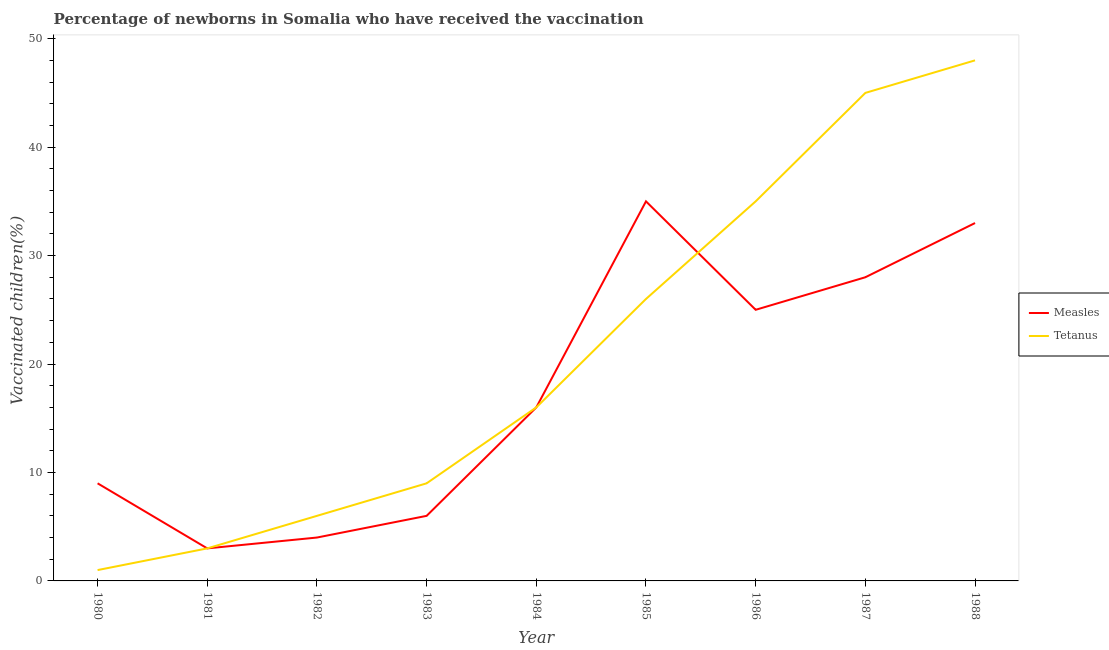What is the percentage of newborns who received vaccination for measles in 1985?
Make the answer very short. 35. Across all years, what is the maximum percentage of newborns who received vaccination for tetanus?
Give a very brief answer. 48. Across all years, what is the minimum percentage of newborns who received vaccination for tetanus?
Your answer should be very brief. 1. What is the total percentage of newborns who received vaccination for tetanus in the graph?
Make the answer very short. 189. What is the difference between the percentage of newborns who received vaccination for measles in 1983 and that in 1984?
Offer a very short reply. -10. What is the difference between the percentage of newborns who received vaccination for measles in 1986 and the percentage of newborns who received vaccination for tetanus in 1987?
Your response must be concise. -20. What is the average percentage of newborns who received vaccination for tetanus per year?
Your response must be concise. 21. In the year 1986, what is the difference between the percentage of newborns who received vaccination for tetanus and percentage of newborns who received vaccination for measles?
Provide a succinct answer. 10. In how many years, is the percentage of newborns who received vaccination for measles greater than 18 %?
Offer a very short reply. 4. What is the ratio of the percentage of newborns who received vaccination for tetanus in 1986 to that in 1988?
Offer a very short reply. 0.73. What is the difference between the highest and the second highest percentage of newborns who received vaccination for tetanus?
Ensure brevity in your answer.  3. What is the difference between the highest and the lowest percentage of newborns who received vaccination for tetanus?
Ensure brevity in your answer.  47. In how many years, is the percentage of newborns who received vaccination for tetanus greater than the average percentage of newborns who received vaccination for tetanus taken over all years?
Provide a short and direct response. 4. Does the percentage of newborns who received vaccination for tetanus monotonically increase over the years?
Your answer should be compact. Yes. Is the percentage of newborns who received vaccination for tetanus strictly greater than the percentage of newborns who received vaccination for measles over the years?
Provide a succinct answer. No. What is the difference between two consecutive major ticks on the Y-axis?
Keep it short and to the point. 10. Does the graph contain any zero values?
Your answer should be very brief. No. Where does the legend appear in the graph?
Offer a terse response. Center right. How many legend labels are there?
Your answer should be compact. 2. What is the title of the graph?
Keep it short and to the point. Percentage of newborns in Somalia who have received the vaccination. What is the label or title of the X-axis?
Ensure brevity in your answer.  Year. What is the label or title of the Y-axis?
Provide a short and direct response. Vaccinated children(%)
. What is the Vaccinated children(%)
 in Measles in 1980?
Give a very brief answer. 9. What is the Vaccinated children(%)
 of Tetanus in 1980?
Make the answer very short. 1. What is the Vaccinated children(%)
 in Measles in 1982?
Offer a terse response. 4. What is the Vaccinated children(%)
 of Measles in 1983?
Provide a succinct answer. 6. What is the Vaccinated children(%)
 of Measles in 1984?
Your answer should be compact. 16. What is the Vaccinated children(%)
 in Tetanus in 1984?
Offer a very short reply. 16. What is the Vaccinated children(%)
 of Tetanus in 1986?
Give a very brief answer. 35. Across all years, what is the minimum Vaccinated children(%)
 of Tetanus?
Your answer should be very brief. 1. What is the total Vaccinated children(%)
 of Measles in the graph?
Make the answer very short. 159. What is the total Vaccinated children(%)
 of Tetanus in the graph?
Give a very brief answer. 189. What is the difference between the Vaccinated children(%)
 of Measles in 1980 and that in 1981?
Keep it short and to the point. 6. What is the difference between the Vaccinated children(%)
 in Tetanus in 1980 and that in 1981?
Your response must be concise. -2. What is the difference between the Vaccinated children(%)
 in Measles in 1980 and that in 1983?
Your response must be concise. 3. What is the difference between the Vaccinated children(%)
 in Tetanus in 1980 and that in 1985?
Keep it short and to the point. -25. What is the difference between the Vaccinated children(%)
 of Tetanus in 1980 and that in 1986?
Offer a terse response. -34. What is the difference between the Vaccinated children(%)
 of Measles in 1980 and that in 1987?
Provide a succinct answer. -19. What is the difference between the Vaccinated children(%)
 of Tetanus in 1980 and that in 1987?
Your answer should be very brief. -44. What is the difference between the Vaccinated children(%)
 of Measles in 1980 and that in 1988?
Your answer should be compact. -24. What is the difference between the Vaccinated children(%)
 in Tetanus in 1980 and that in 1988?
Ensure brevity in your answer.  -47. What is the difference between the Vaccinated children(%)
 of Measles in 1981 and that in 1982?
Give a very brief answer. -1. What is the difference between the Vaccinated children(%)
 in Measles in 1981 and that in 1983?
Keep it short and to the point. -3. What is the difference between the Vaccinated children(%)
 in Measles in 1981 and that in 1984?
Your answer should be very brief. -13. What is the difference between the Vaccinated children(%)
 of Measles in 1981 and that in 1985?
Offer a very short reply. -32. What is the difference between the Vaccinated children(%)
 in Tetanus in 1981 and that in 1986?
Ensure brevity in your answer.  -32. What is the difference between the Vaccinated children(%)
 in Measles in 1981 and that in 1987?
Make the answer very short. -25. What is the difference between the Vaccinated children(%)
 of Tetanus in 1981 and that in 1987?
Your answer should be compact. -42. What is the difference between the Vaccinated children(%)
 of Tetanus in 1981 and that in 1988?
Provide a succinct answer. -45. What is the difference between the Vaccinated children(%)
 of Tetanus in 1982 and that in 1984?
Give a very brief answer. -10. What is the difference between the Vaccinated children(%)
 of Measles in 1982 and that in 1985?
Give a very brief answer. -31. What is the difference between the Vaccinated children(%)
 of Measles in 1982 and that in 1986?
Offer a terse response. -21. What is the difference between the Vaccinated children(%)
 in Tetanus in 1982 and that in 1986?
Offer a terse response. -29. What is the difference between the Vaccinated children(%)
 of Measles in 1982 and that in 1987?
Offer a terse response. -24. What is the difference between the Vaccinated children(%)
 of Tetanus in 1982 and that in 1987?
Your response must be concise. -39. What is the difference between the Vaccinated children(%)
 of Tetanus in 1982 and that in 1988?
Provide a short and direct response. -42. What is the difference between the Vaccinated children(%)
 of Measles in 1983 and that in 1984?
Offer a terse response. -10. What is the difference between the Vaccinated children(%)
 in Tetanus in 1983 and that in 1984?
Your answer should be compact. -7. What is the difference between the Vaccinated children(%)
 of Tetanus in 1983 and that in 1985?
Your answer should be very brief. -17. What is the difference between the Vaccinated children(%)
 in Measles in 1983 and that in 1986?
Your response must be concise. -19. What is the difference between the Vaccinated children(%)
 of Measles in 1983 and that in 1987?
Provide a succinct answer. -22. What is the difference between the Vaccinated children(%)
 of Tetanus in 1983 and that in 1987?
Your answer should be compact. -36. What is the difference between the Vaccinated children(%)
 in Measles in 1983 and that in 1988?
Give a very brief answer. -27. What is the difference between the Vaccinated children(%)
 of Tetanus in 1983 and that in 1988?
Keep it short and to the point. -39. What is the difference between the Vaccinated children(%)
 in Tetanus in 1984 and that in 1985?
Your answer should be compact. -10. What is the difference between the Vaccinated children(%)
 of Measles in 1984 and that in 1987?
Your answer should be compact. -12. What is the difference between the Vaccinated children(%)
 of Tetanus in 1984 and that in 1988?
Provide a succinct answer. -32. What is the difference between the Vaccinated children(%)
 in Measles in 1985 and that in 1987?
Provide a succinct answer. 7. What is the difference between the Vaccinated children(%)
 in Tetanus in 1985 and that in 1987?
Provide a succinct answer. -19. What is the difference between the Vaccinated children(%)
 of Measles in 1985 and that in 1988?
Provide a short and direct response. 2. What is the difference between the Vaccinated children(%)
 in Measles in 1986 and that in 1987?
Keep it short and to the point. -3. What is the difference between the Vaccinated children(%)
 in Tetanus in 1986 and that in 1987?
Your answer should be very brief. -10. What is the difference between the Vaccinated children(%)
 of Measles in 1986 and that in 1988?
Offer a very short reply. -8. What is the difference between the Vaccinated children(%)
 in Tetanus in 1986 and that in 1988?
Your answer should be compact. -13. What is the difference between the Vaccinated children(%)
 in Measles in 1987 and that in 1988?
Your answer should be very brief. -5. What is the difference between the Vaccinated children(%)
 in Measles in 1980 and the Vaccinated children(%)
 in Tetanus in 1984?
Offer a terse response. -7. What is the difference between the Vaccinated children(%)
 in Measles in 1980 and the Vaccinated children(%)
 in Tetanus in 1986?
Give a very brief answer. -26. What is the difference between the Vaccinated children(%)
 of Measles in 1980 and the Vaccinated children(%)
 of Tetanus in 1987?
Keep it short and to the point. -36. What is the difference between the Vaccinated children(%)
 of Measles in 1980 and the Vaccinated children(%)
 of Tetanus in 1988?
Provide a succinct answer. -39. What is the difference between the Vaccinated children(%)
 in Measles in 1981 and the Vaccinated children(%)
 in Tetanus in 1983?
Give a very brief answer. -6. What is the difference between the Vaccinated children(%)
 of Measles in 1981 and the Vaccinated children(%)
 of Tetanus in 1984?
Your answer should be compact. -13. What is the difference between the Vaccinated children(%)
 of Measles in 1981 and the Vaccinated children(%)
 of Tetanus in 1986?
Ensure brevity in your answer.  -32. What is the difference between the Vaccinated children(%)
 in Measles in 1981 and the Vaccinated children(%)
 in Tetanus in 1987?
Provide a short and direct response. -42. What is the difference between the Vaccinated children(%)
 in Measles in 1981 and the Vaccinated children(%)
 in Tetanus in 1988?
Offer a very short reply. -45. What is the difference between the Vaccinated children(%)
 of Measles in 1982 and the Vaccinated children(%)
 of Tetanus in 1983?
Ensure brevity in your answer.  -5. What is the difference between the Vaccinated children(%)
 of Measles in 1982 and the Vaccinated children(%)
 of Tetanus in 1984?
Keep it short and to the point. -12. What is the difference between the Vaccinated children(%)
 in Measles in 1982 and the Vaccinated children(%)
 in Tetanus in 1985?
Give a very brief answer. -22. What is the difference between the Vaccinated children(%)
 in Measles in 1982 and the Vaccinated children(%)
 in Tetanus in 1986?
Give a very brief answer. -31. What is the difference between the Vaccinated children(%)
 in Measles in 1982 and the Vaccinated children(%)
 in Tetanus in 1987?
Your answer should be very brief. -41. What is the difference between the Vaccinated children(%)
 of Measles in 1982 and the Vaccinated children(%)
 of Tetanus in 1988?
Offer a terse response. -44. What is the difference between the Vaccinated children(%)
 in Measles in 1983 and the Vaccinated children(%)
 in Tetanus in 1984?
Your answer should be compact. -10. What is the difference between the Vaccinated children(%)
 of Measles in 1983 and the Vaccinated children(%)
 of Tetanus in 1985?
Offer a terse response. -20. What is the difference between the Vaccinated children(%)
 of Measles in 1983 and the Vaccinated children(%)
 of Tetanus in 1987?
Keep it short and to the point. -39. What is the difference between the Vaccinated children(%)
 of Measles in 1983 and the Vaccinated children(%)
 of Tetanus in 1988?
Offer a very short reply. -42. What is the difference between the Vaccinated children(%)
 in Measles in 1984 and the Vaccinated children(%)
 in Tetanus in 1985?
Give a very brief answer. -10. What is the difference between the Vaccinated children(%)
 of Measles in 1984 and the Vaccinated children(%)
 of Tetanus in 1988?
Provide a short and direct response. -32. What is the difference between the Vaccinated children(%)
 in Measles in 1985 and the Vaccinated children(%)
 in Tetanus in 1987?
Offer a very short reply. -10. What is the difference between the Vaccinated children(%)
 of Measles in 1985 and the Vaccinated children(%)
 of Tetanus in 1988?
Ensure brevity in your answer.  -13. What is the difference between the Vaccinated children(%)
 in Measles in 1987 and the Vaccinated children(%)
 in Tetanus in 1988?
Make the answer very short. -20. What is the average Vaccinated children(%)
 of Measles per year?
Make the answer very short. 17.67. In the year 1984, what is the difference between the Vaccinated children(%)
 of Measles and Vaccinated children(%)
 of Tetanus?
Give a very brief answer. 0. In the year 1985, what is the difference between the Vaccinated children(%)
 of Measles and Vaccinated children(%)
 of Tetanus?
Keep it short and to the point. 9. In the year 1986, what is the difference between the Vaccinated children(%)
 of Measles and Vaccinated children(%)
 of Tetanus?
Provide a short and direct response. -10. What is the ratio of the Vaccinated children(%)
 of Measles in 1980 to that in 1981?
Your answer should be very brief. 3. What is the ratio of the Vaccinated children(%)
 in Measles in 1980 to that in 1982?
Keep it short and to the point. 2.25. What is the ratio of the Vaccinated children(%)
 in Tetanus in 1980 to that in 1982?
Give a very brief answer. 0.17. What is the ratio of the Vaccinated children(%)
 of Measles in 1980 to that in 1983?
Your response must be concise. 1.5. What is the ratio of the Vaccinated children(%)
 in Tetanus in 1980 to that in 1983?
Provide a short and direct response. 0.11. What is the ratio of the Vaccinated children(%)
 in Measles in 1980 to that in 1984?
Offer a very short reply. 0.56. What is the ratio of the Vaccinated children(%)
 in Tetanus in 1980 to that in 1984?
Keep it short and to the point. 0.06. What is the ratio of the Vaccinated children(%)
 of Measles in 1980 to that in 1985?
Your answer should be very brief. 0.26. What is the ratio of the Vaccinated children(%)
 of Tetanus in 1980 to that in 1985?
Your answer should be very brief. 0.04. What is the ratio of the Vaccinated children(%)
 of Measles in 1980 to that in 1986?
Make the answer very short. 0.36. What is the ratio of the Vaccinated children(%)
 in Tetanus in 1980 to that in 1986?
Offer a very short reply. 0.03. What is the ratio of the Vaccinated children(%)
 in Measles in 1980 to that in 1987?
Provide a succinct answer. 0.32. What is the ratio of the Vaccinated children(%)
 in Tetanus in 1980 to that in 1987?
Your answer should be very brief. 0.02. What is the ratio of the Vaccinated children(%)
 of Measles in 1980 to that in 1988?
Your answer should be compact. 0.27. What is the ratio of the Vaccinated children(%)
 in Tetanus in 1980 to that in 1988?
Provide a succinct answer. 0.02. What is the ratio of the Vaccinated children(%)
 in Measles in 1981 to that in 1982?
Your answer should be compact. 0.75. What is the ratio of the Vaccinated children(%)
 of Tetanus in 1981 to that in 1982?
Your answer should be very brief. 0.5. What is the ratio of the Vaccinated children(%)
 of Measles in 1981 to that in 1984?
Keep it short and to the point. 0.19. What is the ratio of the Vaccinated children(%)
 of Tetanus in 1981 to that in 1984?
Make the answer very short. 0.19. What is the ratio of the Vaccinated children(%)
 of Measles in 1981 to that in 1985?
Provide a short and direct response. 0.09. What is the ratio of the Vaccinated children(%)
 of Tetanus in 1981 to that in 1985?
Offer a very short reply. 0.12. What is the ratio of the Vaccinated children(%)
 in Measles in 1981 to that in 1986?
Ensure brevity in your answer.  0.12. What is the ratio of the Vaccinated children(%)
 of Tetanus in 1981 to that in 1986?
Provide a short and direct response. 0.09. What is the ratio of the Vaccinated children(%)
 of Measles in 1981 to that in 1987?
Make the answer very short. 0.11. What is the ratio of the Vaccinated children(%)
 of Tetanus in 1981 to that in 1987?
Offer a terse response. 0.07. What is the ratio of the Vaccinated children(%)
 of Measles in 1981 to that in 1988?
Your response must be concise. 0.09. What is the ratio of the Vaccinated children(%)
 of Tetanus in 1981 to that in 1988?
Provide a succinct answer. 0.06. What is the ratio of the Vaccinated children(%)
 of Measles in 1982 to that in 1985?
Offer a terse response. 0.11. What is the ratio of the Vaccinated children(%)
 of Tetanus in 1982 to that in 1985?
Give a very brief answer. 0.23. What is the ratio of the Vaccinated children(%)
 of Measles in 1982 to that in 1986?
Offer a very short reply. 0.16. What is the ratio of the Vaccinated children(%)
 of Tetanus in 1982 to that in 1986?
Your answer should be compact. 0.17. What is the ratio of the Vaccinated children(%)
 in Measles in 1982 to that in 1987?
Your answer should be very brief. 0.14. What is the ratio of the Vaccinated children(%)
 of Tetanus in 1982 to that in 1987?
Give a very brief answer. 0.13. What is the ratio of the Vaccinated children(%)
 in Measles in 1982 to that in 1988?
Give a very brief answer. 0.12. What is the ratio of the Vaccinated children(%)
 in Tetanus in 1982 to that in 1988?
Ensure brevity in your answer.  0.12. What is the ratio of the Vaccinated children(%)
 of Measles in 1983 to that in 1984?
Offer a very short reply. 0.38. What is the ratio of the Vaccinated children(%)
 of Tetanus in 1983 to that in 1984?
Ensure brevity in your answer.  0.56. What is the ratio of the Vaccinated children(%)
 of Measles in 1983 to that in 1985?
Your response must be concise. 0.17. What is the ratio of the Vaccinated children(%)
 in Tetanus in 1983 to that in 1985?
Provide a short and direct response. 0.35. What is the ratio of the Vaccinated children(%)
 of Measles in 1983 to that in 1986?
Provide a succinct answer. 0.24. What is the ratio of the Vaccinated children(%)
 in Tetanus in 1983 to that in 1986?
Your response must be concise. 0.26. What is the ratio of the Vaccinated children(%)
 of Measles in 1983 to that in 1987?
Give a very brief answer. 0.21. What is the ratio of the Vaccinated children(%)
 in Measles in 1983 to that in 1988?
Make the answer very short. 0.18. What is the ratio of the Vaccinated children(%)
 in Tetanus in 1983 to that in 1988?
Offer a terse response. 0.19. What is the ratio of the Vaccinated children(%)
 of Measles in 1984 to that in 1985?
Provide a short and direct response. 0.46. What is the ratio of the Vaccinated children(%)
 of Tetanus in 1984 to that in 1985?
Provide a short and direct response. 0.62. What is the ratio of the Vaccinated children(%)
 of Measles in 1984 to that in 1986?
Provide a short and direct response. 0.64. What is the ratio of the Vaccinated children(%)
 in Tetanus in 1984 to that in 1986?
Offer a terse response. 0.46. What is the ratio of the Vaccinated children(%)
 in Measles in 1984 to that in 1987?
Make the answer very short. 0.57. What is the ratio of the Vaccinated children(%)
 in Tetanus in 1984 to that in 1987?
Offer a terse response. 0.36. What is the ratio of the Vaccinated children(%)
 of Measles in 1984 to that in 1988?
Provide a succinct answer. 0.48. What is the ratio of the Vaccinated children(%)
 in Tetanus in 1984 to that in 1988?
Ensure brevity in your answer.  0.33. What is the ratio of the Vaccinated children(%)
 in Measles in 1985 to that in 1986?
Make the answer very short. 1.4. What is the ratio of the Vaccinated children(%)
 of Tetanus in 1985 to that in 1986?
Provide a short and direct response. 0.74. What is the ratio of the Vaccinated children(%)
 of Measles in 1985 to that in 1987?
Provide a short and direct response. 1.25. What is the ratio of the Vaccinated children(%)
 in Tetanus in 1985 to that in 1987?
Offer a terse response. 0.58. What is the ratio of the Vaccinated children(%)
 in Measles in 1985 to that in 1988?
Your answer should be very brief. 1.06. What is the ratio of the Vaccinated children(%)
 in Tetanus in 1985 to that in 1988?
Give a very brief answer. 0.54. What is the ratio of the Vaccinated children(%)
 in Measles in 1986 to that in 1987?
Provide a short and direct response. 0.89. What is the ratio of the Vaccinated children(%)
 of Measles in 1986 to that in 1988?
Make the answer very short. 0.76. What is the ratio of the Vaccinated children(%)
 of Tetanus in 1986 to that in 1988?
Your response must be concise. 0.73. What is the ratio of the Vaccinated children(%)
 of Measles in 1987 to that in 1988?
Your response must be concise. 0.85. What is the difference between the highest and the lowest Vaccinated children(%)
 in Measles?
Provide a succinct answer. 32. What is the difference between the highest and the lowest Vaccinated children(%)
 of Tetanus?
Your answer should be compact. 47. 